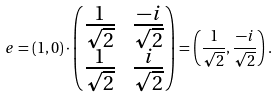Convert formula to latex. <formula><loc_0><loc_0><loc_500><loc_500>e = \left ( 1 , 0 \right ) \cdot \left ( \begin{matrix} \frac { 1 } { \sqrt { 2 } } & \frac { - i } { \sqrt { 2 } } \\ \frac { 1 } { \sqrt { 2 } } & \frac { i } { \sqrt { 2 } } \end{matrix} \right ) = \left ( \frac { 1 } { \sqrt { 2 } } , \frac { - i } { \sqrt { 2 } } \right ) .</formula> 